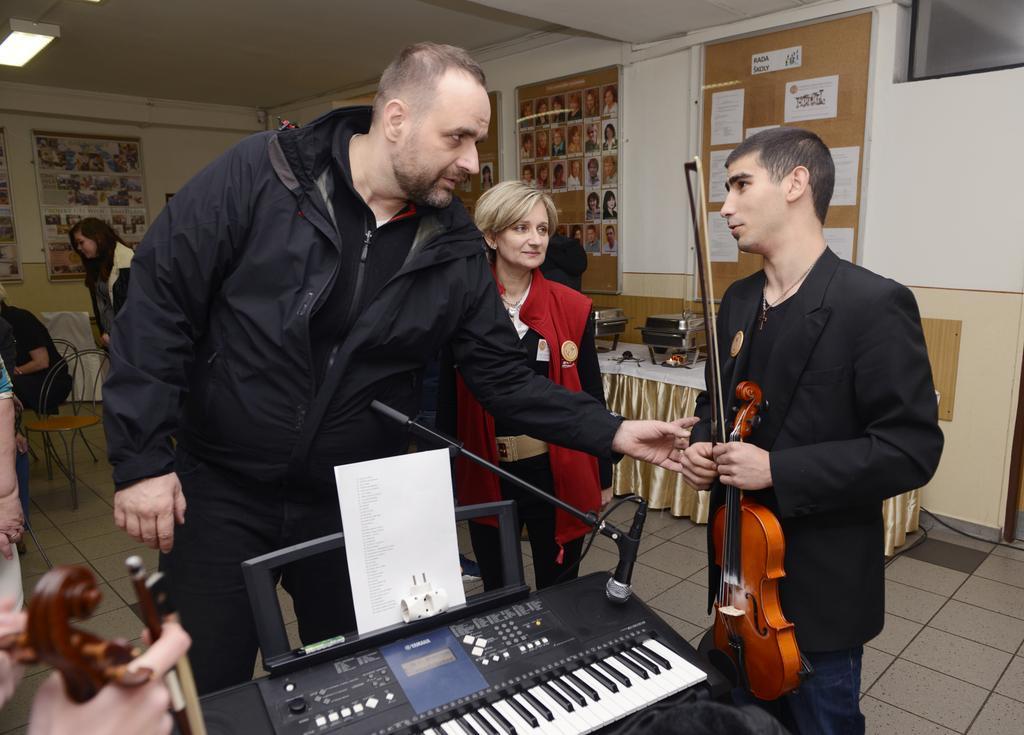Can you describe this image briefly? In this picture we can see three persons are standing on the floor. he is holding a guitar with his hands. And this is piano. On the background we can see a wall and these are the frames. This is table and there is a light. 